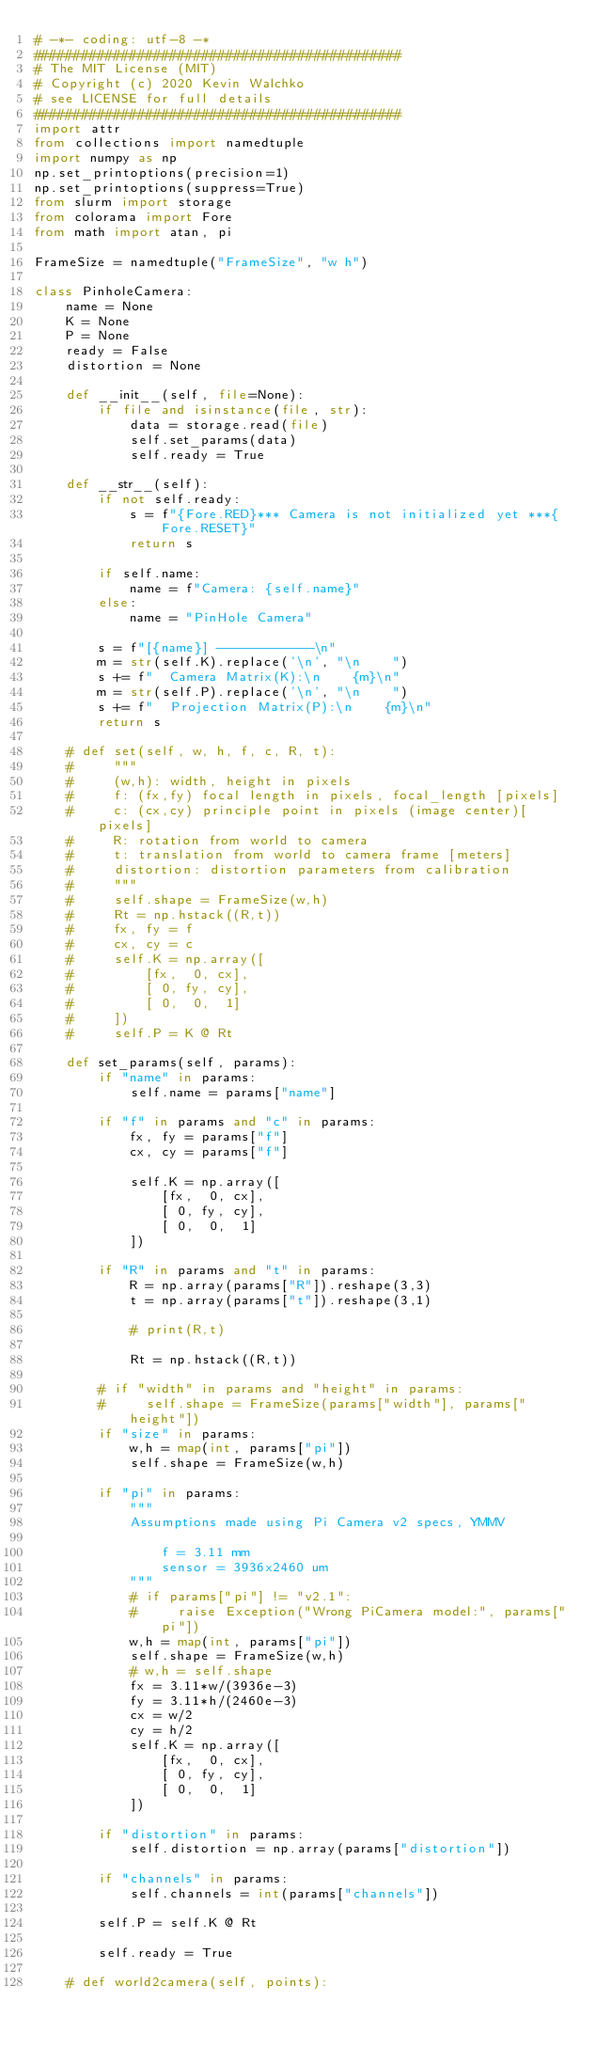Convert code to text. <code><loc_0><loc_0><loc_500><loc_500><_Python_># -*- coding: utf-8 -*
##############################################
# The MIT License (MIT)
# Copyright (c) 2020 Kevin Walchko
# see LICENSE for full details
##############################################
import attr
from collections import namedtuple
import numpy as np
np.set_printoptions(precision=1)
np.set_printoptions(suppress=True)
from slurm import storage
from colorama import Fore
from math import atan, pi

FrameSize = namedtuple("FrameSize", "w h")

class PinholeCamera:
    name = None
    K = None
    P = None
    ready = False
    distortion = None

    def __init__(self, file=None):
        if file and isinstance(file, str):
            data = storage.read(file)
            self.set_params(data)
            self.ready = True

    def __str__(self):
        if not self.ready:
            s = f"{Fore.RED}*** Camera is not initialized yet ***{Fore.RESET}"
            return s

        if self.name:
            name = f"Camera: {self.name}"
        else:
            name = "PinHole Camera"

        s = f"[{name}] ------------\n"
        m = str(self.K).replace('\n', "\n    ")
        s += f"  Camera Matrix(K):\n    {m}\n"
        m = str(self.P).replace('\n', "\n    ")
        s += f"  Projection Matrix(P):\n    {m}\n"
        return s

    # def set(self, w, h, f, c, R, t):
    #     """
    #     (w,h): width, height in pixels
    #     f: (fx,fy) focal length in pixels, focal_length [pixels]
    #     c: (cx,cy) principle point in pixels (image center)[pixels]
    #     R: rotation from world to camera
    #     t: translation from world to camera frame [meters]
    #     distortion: distortion parameters from calibration
    #     """
    #     self.shape = FrameSize(w,h)
    #     Rt = np.hstack((R,t))
    #     fx, fy = f
    #     cx, cy = c
    #     self.K = np.array([
    #         [fx,  0, cx],
    #         [ 0, fy, cy],
    #         [ 0,  0,  1]
    #     ])
    #     self.P = K @ Rt

    def set_params(self, params):
        if "name" in params:
            self.name = params["name"]

        if "f" in params and "c" in params:
            fx, fy = params["f"]
            cx, cy = params["f"]

            self.K = np.array([
                [fx,  0, cx],
                [ 0, fy, cy],
                [ 0,  0,  1]
            ])

        if "R" in params and "t" in params:
            R = np.array(params["R"]).reshape(3,3)
            t = np.array(params["t"]).reshape(3,1)

            # print(R,t)

            Rt = np.hstack((R,t))

        # if "width" in params and "height" in params:
        #     self.shape = FrameSize(params["width"], params["height"])
        if "size" in params:
            w,h = map(int, params["pi"])
            self.shape = FrameSize(w,h)

        if "pi" in params:
            """
            Assumptions made using Pi Camera v2 specs, YMMV

                f = 3.11 mm
                sensor = 3936x2460 um
            """
            # if params["pi"] != "v2.1":
            #     raise Exception("Wrong PiCamera model:", params["pi"])
            w,h = map(int, params["pi"])
            self.shape = FrameSize(w,h)
            # w,h = self.shape
            fx = 3.11*w/(3936e-3)
            fy = 3.11*h/(2460e-3)
            cx = w/2
            cy = h/2
            self.K = np.array([
                [fx,  0, cx],
                [ 0, fy, cy],
                [ 0,  0,  1]
            ])

        if "distortion" in params:
            self.distortion = np.array(params["distortion"])

        if "channels" in params:
            self.channels = int(params["channels"])

        self.P = self.K @ Rt

        self.ready = True

    # def world2camera(self, points):</code> 